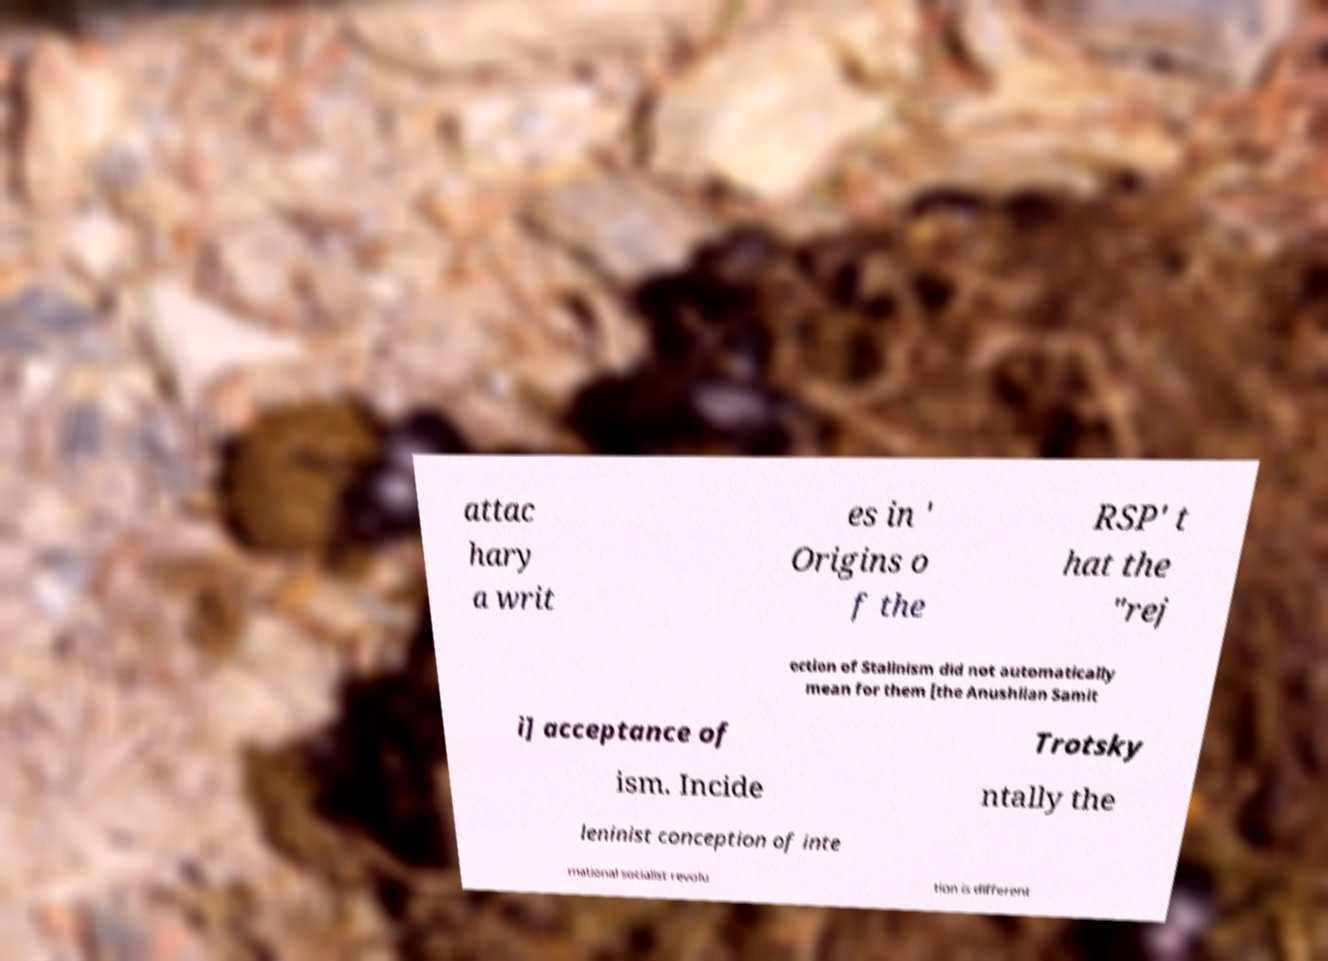Can you read and provide the text displayed in the image?This photo seems to have some interesting text. Can you extract and type it out for me? attac hary a writ es in ' Origins o f the RSP' t hat the "rej ection of Stalinism did not automatically mean for them [the Anushlian Samit i] acceptance of Trotsky ism. Incide ntally the leninist conception of inte rnational socialist revolu tion is different 